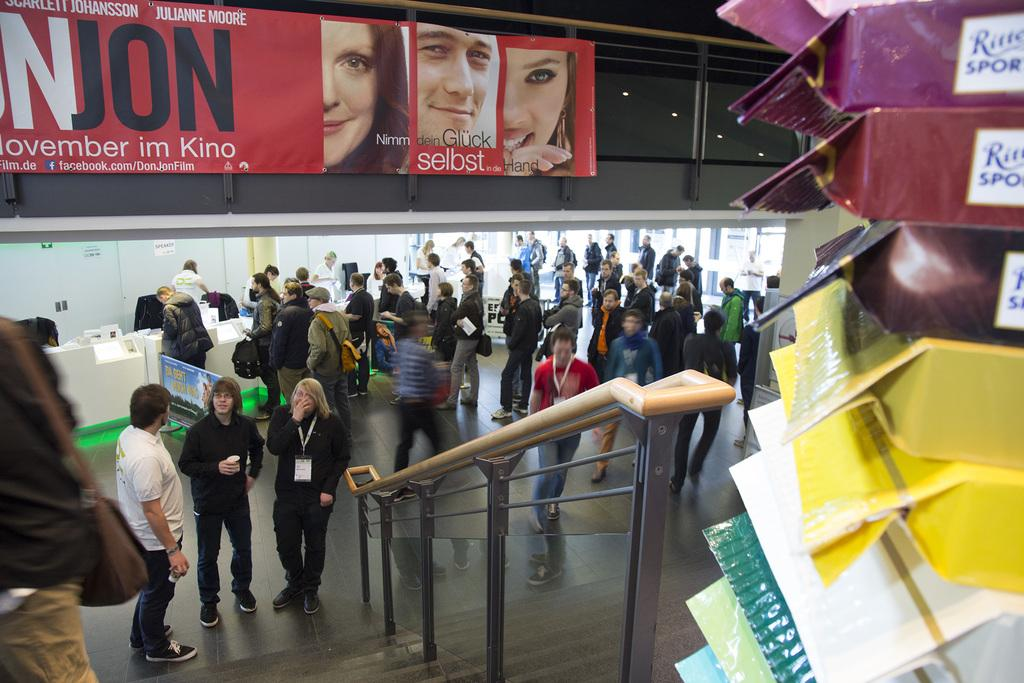What are the people in the image doing? There is a group of people on the floor in the image. What objects can be seen in the image besides the people? There are boards, lights, and glasses in the image. What type of mint is being used to flavor the hot beverage in the image? There is no hot beverage or mint present in the image. 